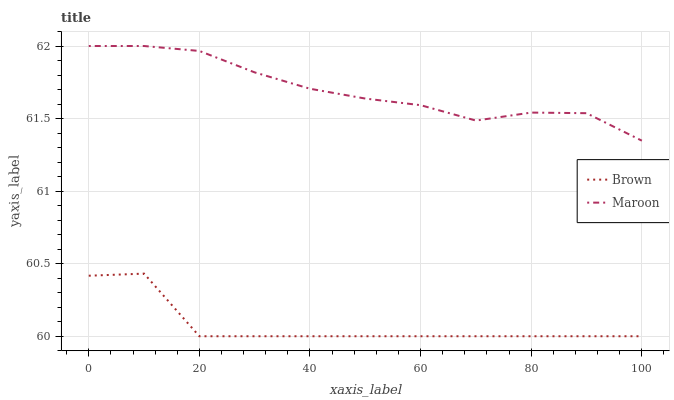Does Brown have the minimum area under the curve?
Answer yes or no. Yes. Does Maroon have the maximum area under the curve?
Answer yes or no. Yes. Does Maroon have the minimum area under the curve?
Answer yes or no. No. Is Maroon the smoothest?
Answer yes or no. Yes. Is Brown the roughest?
Answer yes or no. Yes. Is Maroon the roughest?
Answer yes or no. No. Does Maroon have the lowest value?
Answer yes or no. No. Does Maroon have the highest value?
Answer yes or no. Yes. Is Brown less than Maroon?
Answer yes or no. Yes. Is Maroon greater than Brown?
Answer yes or no. Yes. Does Brown intersect Maroon?
Answer yes or no. No. 